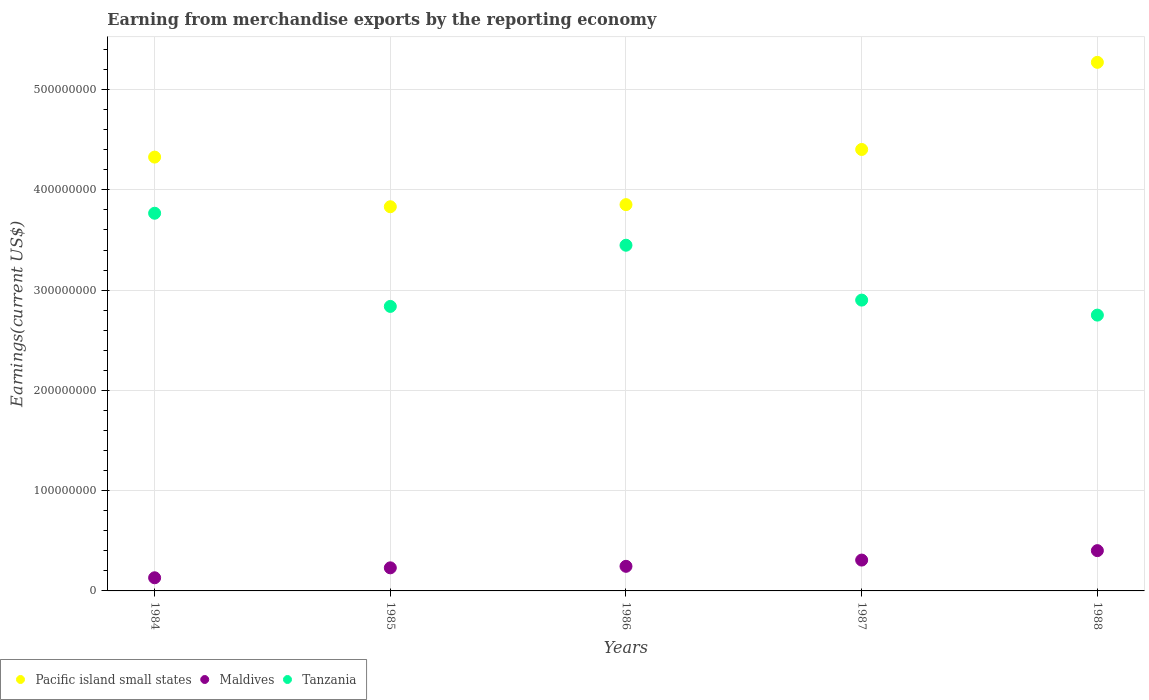How many different coloured dotlines are there?
Your response must be concise. 3. Is the number of dotlines equal to the number of legend labels?
Offer a terse response. Yes. What is the amount earned from merchandise exports in Tanzania in 1985?
Your answer should be very brief. 2.84e+08. Across all years, what is the maximum amount earned from merchandise exports in Pacific island small states?
Ensure brevity in your answer.  5.27e+08. Across all years, what is the minimum amount earned from merchandise exports in Pacific island small states?
Your answer should be compact. 3.83e+08. In which year was the amount earned from merchandise exports in Pacific island small states minimum?
Keep it short and to the point. 1985. What is the total amount earned from merchandise exports in Tanzania in the graph?
Your answer should be very brief. 1.57e+09. What is the difference between the amount earned from merchandise exports in Tanzania in 1984 and that in 1988?
Offer a terse response. 1.02e+08. What is the difference between the amount earned from merchandise exports in Pacific island small states in 1984 and the amount earned from merchandise exports in Maldives in 1988?
Your response must be concise. 3.93e+08. What is the average amount earned from merchandise exports in Maldives per year?
Keep it short and to the point. 2.63e+07. In the year 1987, what is the difference between the amount earned from merchandise exports in Maldives and amount earned from merchandise exports in Pacific island small states?
Your answer should be very brief. -4.10e+08. What is the ratio of the amount earned from merchandise exports in Maldives in 1986 to that in 1987?
Your answer should be very brief. 0.8. Is the amount earned from merchandise exports in Pacific island small states in 1984 less than that in 1987?
Your answer should be very brief. Yes. What is the difference between the highest and the second highest amount earned from merchandise exports in Tanzania?
Your answer should be very brief. 3.19e+07. What is the difference between the highest and the lowest amount earned from merchandise exports in Tanzania?
Offer a very short reply. 1.02e+08. In how many years, is the amount earned from merchandise exports in Pacific island small states greater than the average amount earned from merchandise exports in Pacific island small states taken over all years?
Ensure brevity in your answer.  2. Is it the case that in every year, the sum of the amount earned from merchandise exports in Tanzania and amount earned from merchandise exports in Pacific island small states  is greater than the amount earned from merchandise exports in Maldives?
Ensure brevity in your answer.  Yes. Does the amount earned from merchandise exports in Maldives monotonically increase over the years?
Provide a succinct answer. Yes. Is the amount earned from merchandise exports in Pacific island small states strictly less than the amount earned from merchandise exports in Maldives over the years?
Ensure brevity in your answer.  No. How many dotlines are there?
Give a very brief answer. 3. What is the difference between two consecutive major ticks on the Y-axis?
Offer a terse response. 1.00e+08. Are the values on the major ticks of Y-axis written in scientific E-notation?
Keep it short and to the point. No. Does the graph contain any zero values?
Offer a very short reply. No. How many legend labels are there?
Offer a very short reply. 3. How are the legend labels stacked?
Your answer should be very brief. Horizontal. What is the title of the graph?
Offer a terse response. Earning from merchandise exports by the reporting economy. What is the label or title of the Y-axis?
Your answer should be compact. Earnings(current US$). What is the Earnings(current US$) in Pacific island small states in 1984?
Offer a terse response. 4.33e+08. What is the Earnings(current US$) of Maldives in 1984?
Provide a short and direct response. 1.31e+07. What is the Earnings(current US$) in Tanzania in 1984?
Keep it short and to the point. 3.77e+08. What is the Earnings(current US$) in Pacific island small states in 1985?
Offer a very short reply. 3.83e+08. What is the Earnings(current US$) in Maldives in 1985?
Ensure brevity in your answer.  2.30e+07. What is the Earnings(current US$) of Tanzania in 1985?
Keep it short and to the point. 2.84e+08. What is the Earnings(current US$) of Pacific island small states in 1986?
Your answer should be very brief. 3.85e+08. What is the Earnings(current US$) in Maldives in 1986?
Offer a terse response. 2.45e+07. What is the Earnings(current US$) of Tanzania in 1986?
Provide a short and direct response. 3.45e+08. What is the Earnings(current US$) in Pacific island small states in 1987?
Provide a short and direct response. 4.40e+08. What is the Earnings(current US$) in Maldives in 1987?
Ensure brevity in your answer.  3.08e+07. What is the Earnings(current US$) in Tanzania in 1987?
Your answer should be compact. 2.90e+08. What is the Earnings(current US$) in Pacific island small states in 1988?
Ensure brevity in your answer.  5.27e+08. What is the Earnings(current US$) in Maldives in 1988?
Your response must be concise. 4.02e+07. What is the Earnings(current US$) in Tanzania in 1988?
Your answer should be very brief. 2.75e+08. Across all years, what is the maximum Earnings(current US$) in Pacific island small states?
Provide a short and direct response. 5.27e+08. Across all years, what is the maximum Earnings(current US$) in Maldives?
Ensure brevity in your answer.  4.02e+07. Across all years, what is the maximum Earnings(current US$) in Tanzania?
Your answer should be compact. 3.77e+08. Across all years, what is the minimum Earnings(current US$) in Pacific island small states?
Offer a terse response. 3.83e+08. Across all years, what is the minimum Earnings(current US$) of Maldives?
Your response must be concise. 1.31e+07. Across all years, what is the minimum Earnings(current US$) of Tanzania?
Your answer should be compact. 2.75e+08. What is the total Earnings(current US$) in Pacific island small states in the graph?
Provide a short and direct response. 2.17e+09. What is the total Earnings(current US$) of Maldives in the graph?
Ensure brevity in your answer.  1.32e+08. What is the total Earnings(current US$) in Tanzania in the graph?
Offer a terse response. 1.57e+09. What is the difference between the Earnings(current US$) of Pacific island small states in 1984 and that in 1985?
Offer a very short reply. 4.95e+07. What is the difference between the Earnings(current US$) of Maldives in 1984 and that in 1985?
Provide a succinct answer. -9.92e+06. What is the difference between the Earnings(current US$) in Tanzania in 1984 and that in 1985?
Your answer should be very brief. 9.29e+07. What is the difference between the Earnings(current US$) of Pacific island small states in 1984 and that in 1986?
Provide a succinct answer. 4.74e+07. What is the difference between the Earnings(current US$) in Maldives in 1984 and that in 1986?
Give a very brief answer. -1.14e+07. What is the difference between the Earnings(current US$) of Tanzania in 1984 and that in 1986?
Offer a terse response. 3.19e+07. What is the difference between the Earnings(current US$) of Pacific island small states in 1984 and that in 1987?
Make the answer very short. -7.60e+06. What is the difference between the Earnings(current US$) of Maldives in 1984 and that in 1987?
Your answer should be very brief. -1.77e+07. What is the difference between the Earnings(current US$) in Tanzania in 1984 and that in 1987?
Ensure brevity in your answer.  8.66e+07. What is the difference between the Earnings(current US$) of Pacific island small states in 1984 and that in 1988?
Keep it short and to the point. -9.45e+07. What is the difference between the Earnings(current US$) in Maldives in 1984 and that in 1988?
Provide a short and direct response. -2.71e+07. What is the difference between the Earnings(current US$) of Tanzania in 1984 and that in 1988?
Give a very brief answer. 1.02e+08. What is the difference between the Earnings(current US$) of Pacific island small states in 1985 and that in 1986?
Your answer should be very brief. -2.09e+06. What is the difference between the Earnings(current US$) in Maldives in 1985 and that in 1986?
Your answer should be very brief. -1.51e+06. What is the difference between the Earnings(current US$) of Tanzania in 1985 and that in 1986?
Provide a short and direct response. -6.10e+07. What is the difference between the Earnings(current US$) in Pacific island small states in 1985 and that in 1987?
Your response must be concise. -5.71e+07. What is the difference between the Earnings(current US$) of Maldives in 1985 and that in 1987?
Offer a very short reply. -7.74e+06. What is the difference between the Earnings(current US$) in Tanzania in 1985 and that in 1987?
Provide a short and direct response. -6.29e+06. What is the difference between the Earnings(current US$) of Pacific island small states in 1985 and that in 1988?
Ensure brevity in your answer.  -1.44e+08. What is the difference between the Earnings(current US$) in Maldives in 1985 and that in 1988?
Offer a terse response. -1.72e+07. What is the difference between the Earnings(current US$) of Tanzania in 1985 and that in 1988?
Provide a short and direct response. 8.68e+06. What is the difference between the Earnings(current US$) of Pacific island small states in 1986 and that in 1987?
Keep it short and to the point. -5.50e+07. What is the difference between the Earnings(current US$) of Maldives in 1986 and that in 1987?
Make the answer very short. -6.23e+06. What is the difference between the Earnings(current US$) of Tanzania in 1986 and that in 1987?
Make the answer very short. 5.47e+07. What is the difference between the Earnings(current US$) in Pacific island small states in 1986 and that in 1988?
Provide a succinct answer. -1.42e+08. What is the difference between the Earnings(current US$) of Maldives in 1986 and that in 1988?
Offer a terse response. -1.56e+07. What is the difference between the Earnings(current US$) in Tanzania in 1986 and that in 1988?
Ensure brevity in your answer.  6.97e+07. What is the difference between the Earnings(current US$) of Pacific island small states in 1987 and that in 1988?
Your answer should be very brief. -8.69e+07. What is the difference between the Earnings(current US$) in Maldives in 1987 and that in 1988?
Your answer should be compact. -9.41e+06. What is the difference between the Earnings(current US$) of Tanzania in 1987 and that in 1988?
Your answer should be compact. 1.50e+07. What is the difference between the Earnings(current US$) of Pacific island small states in 1984 and the Earnings(current US$) of Maldives in 1985?
Provide a succinct answer. 4.10e+08. What is the difference between the Earnings(current US$) of Pacific island small states in 1984 and the Earnings(current US$) of Tanzania in 1985?
Keep it short and to the point. 1.49e+08. What is the difference between the Earnings(current US$) in Maldives in 1984 and the Earnings(current US$) in Tanzania in 1985?
Offer a very short reply. -2.71e+08. What is the difference between the Earnings(current US$) in Pacific island small states in 1984 and the Earnings(current US$) in Maldives in 1986?
Your response must be concise. 4.08e+08. What is the difference between the Earnings(current US$) in Pacific island small states in 1984 and the Earnings(current US$) in Tanzania in 1986?
Make the answer very short. 8.79e+07. What is the difference between the Earnings(current US$) of Maldives in 1984 and the Earnings(current US$) of Tanzania in 1986?
Your answer should be compact. -3.32e+08. What is the difference between the Earnings(current US$) of Pacific island small states in 1984 and the Earnings(current US$) of Maldives in 1987?
Give a very brief answer. 4.02e+08. What is the difference between the Earnings(current US$) in Pacific island small states in 1984 and the Earnings(current US$) in Tanzania in 1987?
Your answer should be compact. 1.43e+08. What is the difference between the Earnings(current US$) in Maldives in 1984 and the Earnings(current US$) in Tanzania in 1987?
Your answer should be very brief. -2.77e+08. What is the difference between the Earnings(current US$) of Pacific island small states in 1984 and the Earnings(current US$) of Maldives in 1988?
Provide a succinct answer. 3.93e+08. What is the difference between the Earnings(current US$) in Pacific island small states in 1984 and the Earnings(current US$) in Tanzania in 1988?
Your response must be concise. 1.58e+08. What is the difference between the Earnings(current US$) in Maldives in 1984 and the Earnings(current US$) in Tanzania in 1988?
Offer a very short reply. -2.62e+08. What is the difference between the Earnings(current US$) in Pacific island small states in 1985 and the Earnings(current US$) in Maldives in 1986?
Offer a terse response. 3.59e+08. What is the difference between the Earnings(current US$) of Pacific island small states in 1985 and the Earnings(current US$) of Tanzania in 1986?
Your answer should be very brief. 3.84e+07. What is the difference between the Earnings(current US$) of Maldives in 1985 and the Earnings(current US$) of Tanzania in 1986?
Ensure brevity in your answer.  -3.22e+08. What is the difference between the Earnings(current US$) in Pacific island small states in 1985 and the Earnings(current US$) in Maldives in 1987?
Provide a succinct answer. 3.52e+08. What is the difference between the Earnings(current US$) of Pacific island small states in 1985 and the Earnings(current US$) of Tanzania in 1987?
Your answer should be compact. 9.31e+07. What is the difference between the Earnings(current US$) of Maldives in 1985 and the Earnings(current US$) of Tanzania in 1987?
Give a very brief answer. -2.67e+08. What is the difference between the Earnings(current US$) of Pacific island small states in 1985 and the Earnings(current US$) of Maldives in 1988?
Give a very brief answer. 3.43e+08. What is the difference between the Earnings(current US$) of Pacific island small states in 1985 and the Earnings(current US$) of Tanzania in 1988?
Offer a terse response. 1.08e+08. What is the difference between the Earnings(current US$) of Maldives in 1985 and the Earnings(current US$) of Tanzania in 1988?
Make the answer very short. -2.52e+08. What is the difference between the Earnings(current US$) of Pacific island small states in 1986 and the Earnings(current US$) of Maldives in 1987?
Make the answer very short. 3.54e+08. What is the difference between the Earnings(current US$) of Pacific island small states in 1986 and the Earnings(current US$) of Tanzania in 1987?
Your answer should be compact. 9.52e+07. What is the difference between the Earnings(current US$) of Maldives in 1986 and the Earnings(current US$) of Tanzania in 1987?
Keep it short and to the point. -2.66e+08. What is the difference between the Earnings(current US$) of Pacific island small states in 1986 and the Earnings(current US$) of Maldives in 1988?
Provide a succinct answer. 3.45e+08. What is the difference between the Earnings(current US$) in Pacific island small states in 1986 and the Earnings(current US$) in Tanzania in 1988?
Your answer should be compact. 1.10e+08. What is the difference between the Earnings(current US$) in Maldives in 1986 and the Earnings(current US$) in Tanzania in 1988?
Provide a succinct answer. -2.51e+08. What is the difference between the Earnings(current US$) in Pacific island small states in 1987 and the Earnings(current US$) in Maldives in 1988?
Your answer should be very brief. 4.00e+08. What is the difference between the Earnings(current US$) in Pacific island small states in 1987 and the Earnings(current US$) in Tanzania in 1988?
Give a very brief answer. 1.65e+08. What is the difference between the Earnings(current US$) in Maldives in 1987 and the Earnings(current US$) in Tanzania in 1988?
Give a very brief answer. -2.44e+08. What is the average Earnings(current US$) in Pacific island small states per year?
Ensure brevity in your answer.  4.34e+08. What is the average Earnings(current US$) in Maldives per year?
Your answer should be compact. 2.63e+07. What is the average Earnings(current US$) of Tanzania per year?
Make the answer very short. 3.14e+08. In the year 1984, what is the difference between the Earnings(current US$) of Pacific island small states and Earnings(current US$) of Maldives?
Provide a short and direct response. 4.20e+08. In the year 1984, what is the difference between the Earnings(current US$) of Pacific island small states and Earnings(current US$) of Tanzania?
Your answer should be compact. 5.60e+07. In the year 1984, what is the difference between the Earnings(current US$) in Maldives and Earnings(current US$) in Tanzania?
Your answer should be compact. -3.64e+08. In the year 1985, what is the difference between the Earnings(current US$) in Pacific island small states and Earnings(current US$) in Maldives?
Keep it short and to the point. 3.60e+08. In the year 1985, what is the difference between the Earnings(current US$) in Pacific island small states and Earnings(current US$) in Tanzania?
Provide a short and direct response. 9.94e+07. In the year 1985, what is the difference between the Earnings(current US$) of Maldives and Earnings(current US$) of Tanzania?
Give a very brief answer. -2.61e+08. In the year 1986, what is the difference between the Earnings(current US$) in Pacific island small states and Earnings(current US$) in Maldives?
Give a very brief answer. 3.61e+08. In the year 1986, what is the difference between the Earnings(current US$) of Pacific island small states and Earnings(current US$) of Tanzania?
Your answer should be compact. 4.05e+07. In the year 1986, what is the difference between the Earnings(current US$) of Maldives and Earnings(current US$) of Tanzania?
Provide a short and direct response. -3.20e+08. In the year 1987, what is the difference between the Earnings(current US$) of Pacific island small states and Earnings(current US$) of Maldives?
Your answer should be very brief. 4.10e+08. In the year 1987, what is the difference between the Earnings(current US$) of Pacific island small states and Earnings(current US$) of Tanzania?
Your response must be concise. 1.50e+08. In the year 1987, what is the difference between the Earnings(current US$) of Maldives and Earnings(current US$) of Tanzania?
Give a very brief answer. -2.59e+08. In the year 1988, what is the difference between the Earnings(current US$) of Pacific island small states and Earnings(current US$) of Maldives?
Your answer should be compact. 4.87e+08. In the year 1988, what is the difference between the Earnings(current US$) in Pacific island small states and Earnings(current US$) in Tanzania?
Make the answer very short. 2.52e+08. In the year 1988, what is the difference between the Earnings(current US$) of Maldives and Earnings(current US$) of Tanzania?
Give a very brief answer. -2.35e+08. What is the ratio of the Earnings(current US$) in Pacific island small states in 1984 to that in 1985?
Your answer should be compact. 1.13. What is the ratio of the Earnings(current US$) in Maldives in 1984 to that in 1985?
Offer a very short reply. 0.57. What is the ratio of the Earnings(current US$) in Tanzania in 1984 to that in 1985?
Your response must be concise. 1.33. What is the ratio of the Earnings(current US$) in Pacific island small states in 1984 to that in 1986?
Make the answer very short. 1.12. What is the ratio of the Earnings(current US$) in Maldives in 1984 to that in 1986?
Make the answer very short. 0.53. What is the ratio of the Earnings(current US$) in Tanzania in 1984 to that in 1986?
Keep it short and to the point. 1.09. What is the ratio of the Earnings(current US$) in Pacific island small states in 1984 to that in 1987?
Ensure brevity in your answer.  0.98. What is the ratio of the Earnings(current US$) of Maldives in 1984 to that in 1987?
Keep it short and to the point. 0.43. What is the ratio of the Earnings(current US$) of Tanzania in 1984 to that in 1987?
Provide a short and direct response. 1.3. What is the ratio of the Earnings(current US$) in Pacific island small states in 1984 to that in 1988?
Your response must be concise. 0.82. What is the ratio of the Earnings(current US$) of Maldives in 1984 to that in 1988?
Your answer should be very brief. 0.33. What is the ratio of the Earnings(current US$) in Tanzania in 1984 to that in 1988?
Provide a succinct answer. 1.37. What is the ratio of the Earnings(current US$) of Maldives in 1985 to that in 1986?
Your answer should be very brief. 0.94. What is the ratio of the Earnings(current US$) in Tanzania in 1985 to that in 1986?
Your response must be concise. 0.82. What is the ratio of the Earnings(current US$) of Pacific island small states in 1985 to that in 1987?
Offer a terse response. 0.87. What is the ratio of the Earnings(current US$) of Maldives in 1985 to that in 1987?
Your answer should be very brief. 0.75. What is the ratio of the Earnings(current US$) in Tanzania in 1985 to that in 1987?
Provide a short and direct response. 0.98. What is the ratio of the Earnings(current US$) of Pacific island small states in 1985 to that in 1988?
Provide a short and direct response. 0.73. What is the ratio of the Earnings(current US$) of Maldives in 1985 to that in 1988?
Your answer should be very brief. 0.57. What is the ratio of the Earnings(current US$) of Tanzania in 1985 to that in 1988?
Ensure brevity in your answer.  1.03. What is the ratio of the Earnings(current US$) in Maldives in 1986 to that in 1987?
Your answer should be compact. 0.8. What is the ratio of the Earnings(current US$) in Tanzania in 1986 to that in 1987?
Give a very brief answer. 1.19. What is the ratio of the Earnings(current US$) of Pacific island small states in 1986 to that in 1988?
Make the answer very short. 0.73. What is the ratio of the Earnings(current US$) of Maldives in 1986 to that in 1988?
Offer a very short reply. 0.61. What is the ratio of the Earnings(current US$) of Tanzania in 1986 to that in 1988?
Make the answer very short. 1.25. What is the ratio of the Earnings(current US$) in Pacific island small states in 1987 to that in 1988?
Your answer should be very brief. 0.84. What is the ratio of the Earnings(current US$) of Maldives in 1987 to that in 1988?
Make the answer very short. 0.77. What is the ratio of the Earnings(current US$) of Tanzania in 1987 to that in 1988?
Offer a very short reply. 1.05. What is the difference between the highest and the second highest Earnings(current US$) of Pacific island small states?
Your answer should be compact. 8.69e+07. What is the difference between the highest and the second highest Earnings(current US$) in Maldives?
Keep it short and to the point. 9.41e+06. What is the difference between the highest and the second highest Earnings(current US$) in Tanzania?
Your answer should be compact. 3.19e+07. What is the difference between the highest and the lowest Earnings(current US$) in Pacific island small states?
Ensure brevity in your answer.  1.44e+08. What is the difference between the highest and the lowest Earnings(current US$) in Maldives?
Your answer should be very brief. 2.71e+07. What is the difference between the highest and the lowest Earnings(current US$) in Tanzania?
Provide a succinct answer. 1.02e+08. 